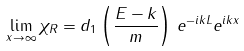<formula> <loc_0><loc_0><loc_500><loc_500>\lim _ { x \to \infty } \chi _ { R } = d _ { 1 } \left ( \frac { E - k } { m } \right ) \, e ^ { - i k L } e ^ { i k x }</formula> 